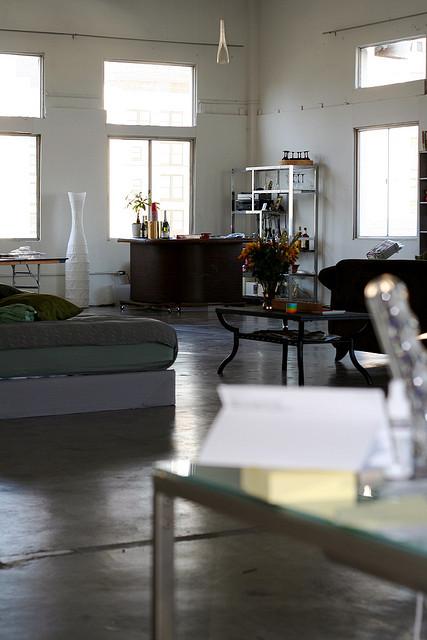Is this a kitchen?
Answer briefly. No. Are there curtains on the windows?
Answer briefly. No. Are there plants in this image?
Give a very brief answer. Yes. 